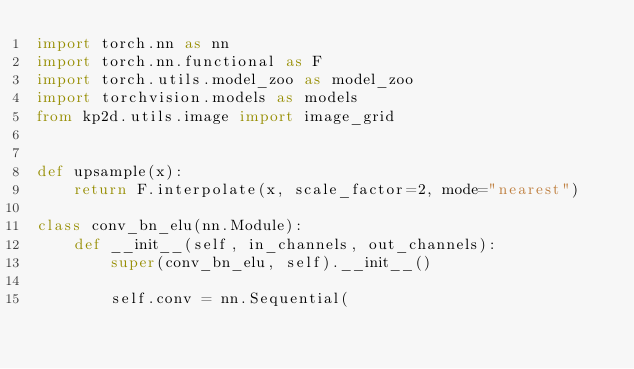Convert code to text. <code><loc_0><loc_0><loc_500><loc_500><_Python_>import torch.nn as nn
import torch.nn.functional as F
import torch.utils.model_zoo as model_zoo
import torchvision.models as models
from kp2d.utils.image import image_grid


def upsample(x):
    return F.interpolate(x, scale_factor=2, mode="nearest")

class conv_bn_elu(nn.Module):
    def __init__(self, in_channels, out_channels):
        super(conv_bn_elu, self).__init__()

        self.conv = nn.Sequential( </code> 